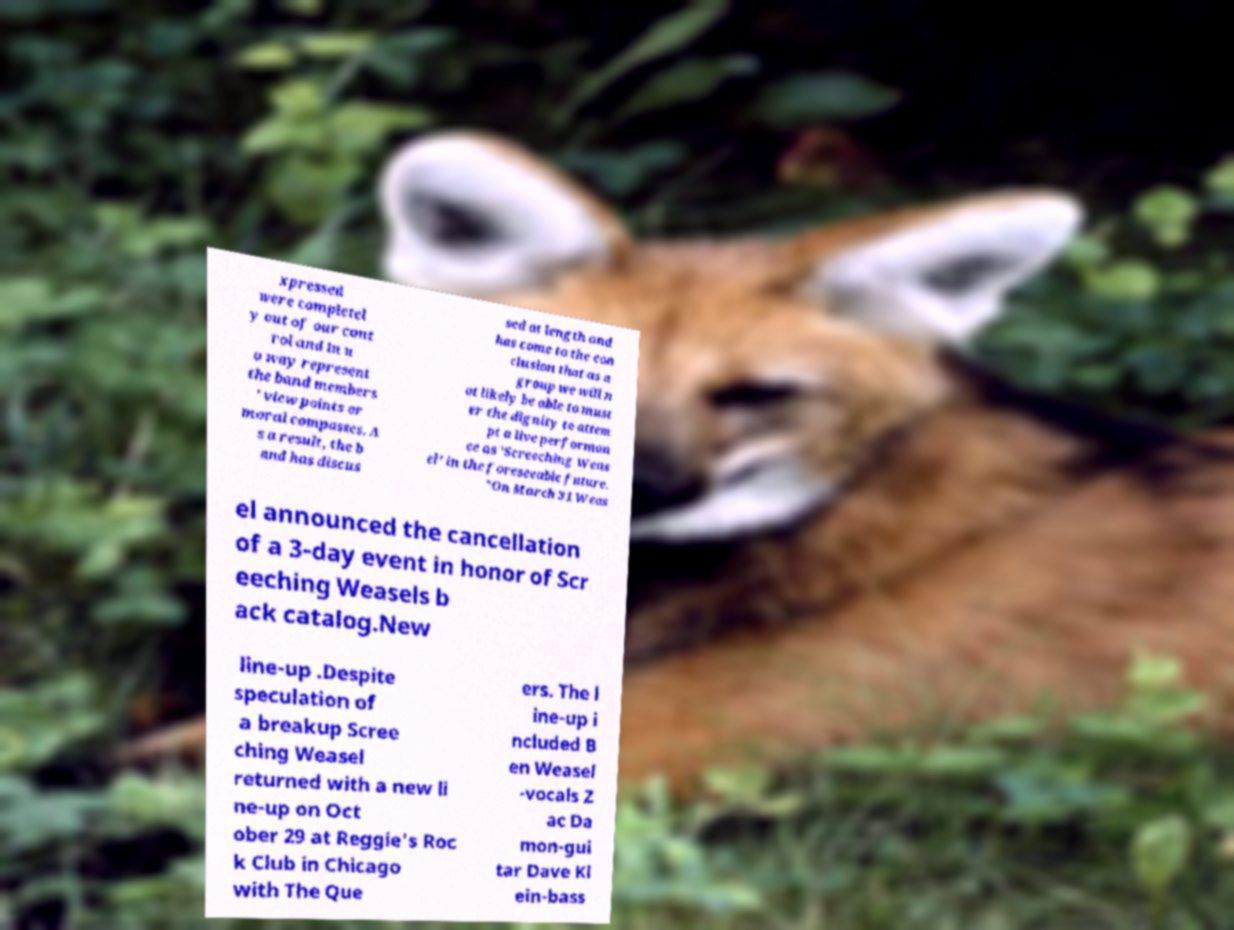Can you read and provide the text displayed in the image?This photo seems to have some interesting text. Can you extract and type it out for me? xpressed were completel y out of our cont rol and in n o way represent the band members ' view points or moral compasses. A s a result, the b and has discus sed at length and has come to the con clusion that as a group we will n ot likely be able to must er the dignity to attem pt a live performan ce as 'Screeching Weas el' in the foreseeable future. "On March 31 Weas el announced the cancellation of a 3-day event in honor of Scr eeching Weasels b ack catalog.New line-up .Despite speculation of a breakup Scree ching Weasel returned with a new li ne-up on Oct ober 29 at Reggie's Roc k Club in Chicago with The Que ers. The l ine-up i ncluded B en Weasel -vocals Z ac Da mon-gui tar Dave Kl ein-bass 